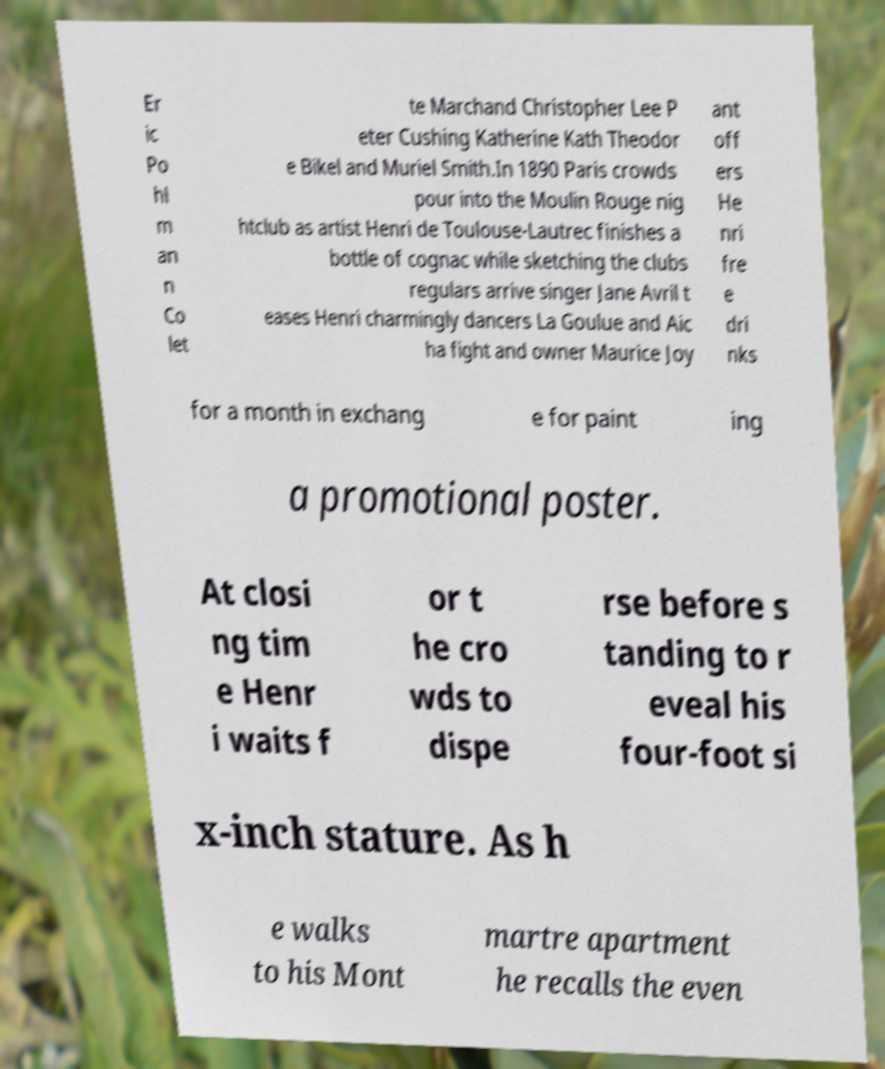Can you accurately transcribe the text from the provided image for me? Er ic Po hl m an n Co let te Marchand Christopher Lee P eter Cushing Katherine Kath Theodor e Bikel and Muriel Smith.In 1890 Paris crowds pour into the Moulin Rouge nig htclub as artist Henri de Toulouse-Lautrec finishes a bottle of cognac while sketching the clubs regulars arrive singer Jane Avril t eases Henri charmingly dancers La Goulue and Aic ha fight and owner Maurice Joy ant off ers He nri fre e dri nks for a month in exchang e for paint ing a promotional poster. At closi ng tim e Henr i waits f or t he cro wds to dispe rse before s tanding to r eveal his four-foot si x-inch stature. As h e walks to his Mont martre apartment he recalls the even 